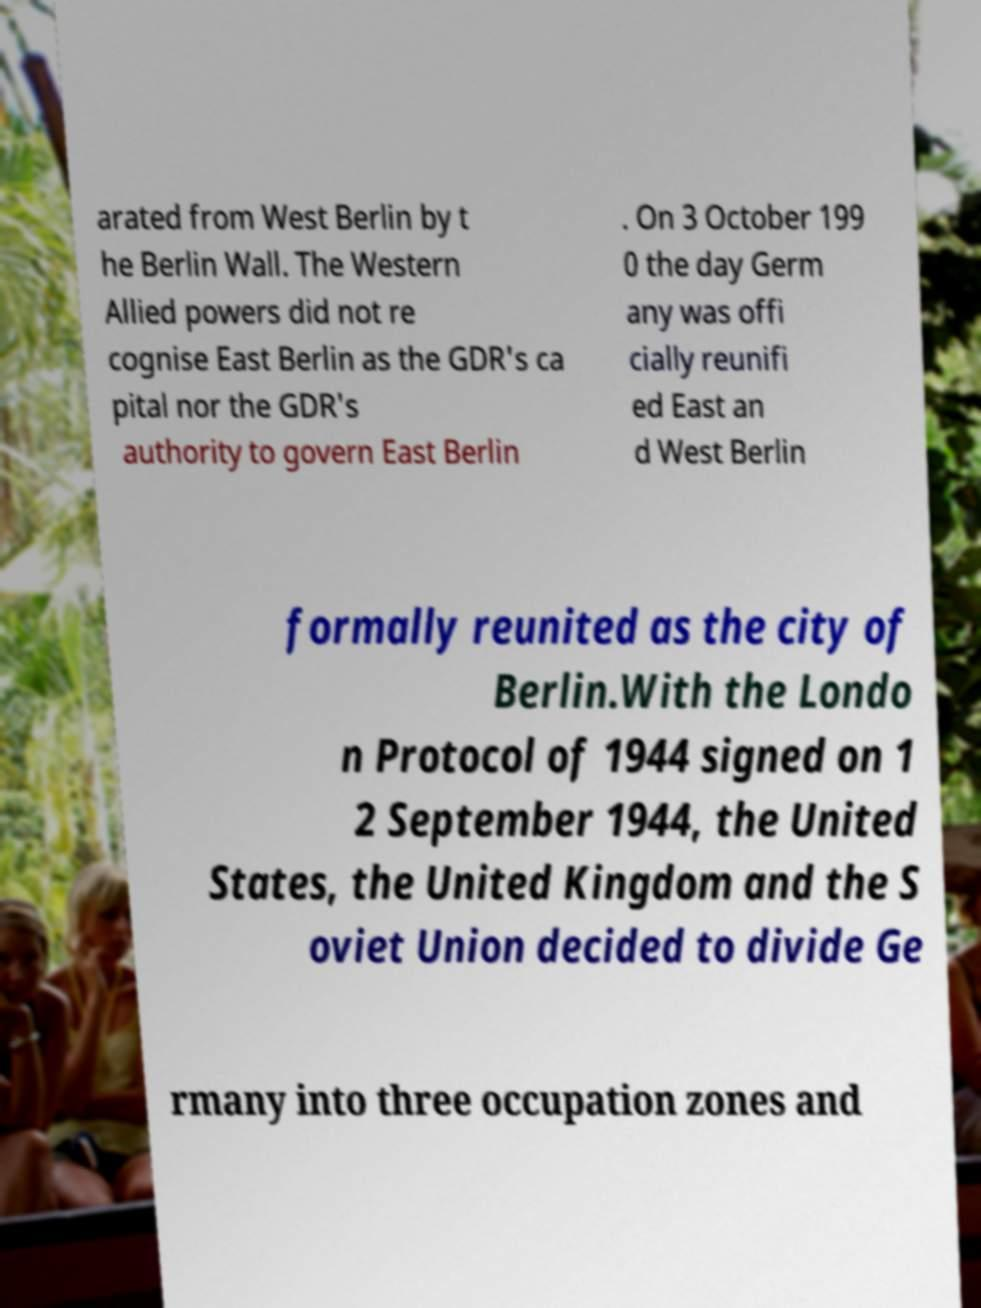Please read and relay the text visible in this image. What does it say? arated from West Berlin by t he Berlin Wall. The Western Allied powers did not re cognise East Berlin as the GDR's ca pital nor the GDR's authority to govern East Berlin . On 3 October 199 0 the day Germ any was offi cially reunifi ed East an d West Berlin formally reunited as the city of Berlin.With the Londo n Protocol of 1944 signed on 1 2 September 1944, the United States, the United Kingdom and the S oviet Union decided to divide Ge rmany into three occupation zones and 